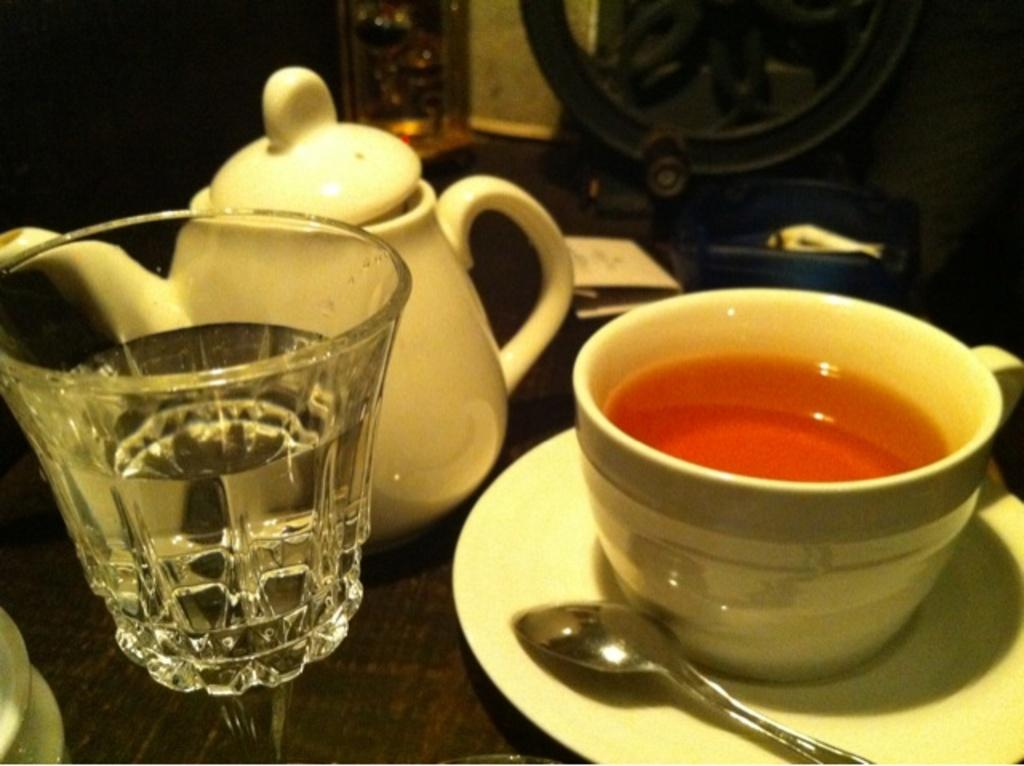What is in the glass that is visible in the image? There is a glass with water in the image. What other items related to beverages can be seen in the image? There is a tea pot and a cup filled with some drink in the image. How is the cup placed on the table? The cup is placed on a saucer, which is then placed on the table. Where are all these items located in the image? All these items are placed on a table. What type of creature is crawling on the earth in the image? There is no creature crawling on the earth in the image; it only features a glass with water, a tea pot, a cup filled with some drink, a saucer, and a table. What type of soda is being served in the cup in the image? The type of drink in the cup cannot be determined from the image, as it is not specified whether it is soda or another beverage. 